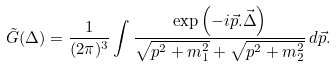Convert formula to latex. <formula><loc_0><loc_0><loc_500><loc_500>\tilde { G } ( \Delta ) = \frac { 1 } { ( 2 \pi ) ^ { 3 } } \int \frac { \exp \left ( - i \vec { p } . \vec { \Delta } \right ) } { \sqrt { p ^ { 2 } + m _ { 1 } ^ { 2 } } + \sqrt { p ^ { 2 } + m _ { 2 } ^ { 2 } } } \, d \vec { p } .</formula> 